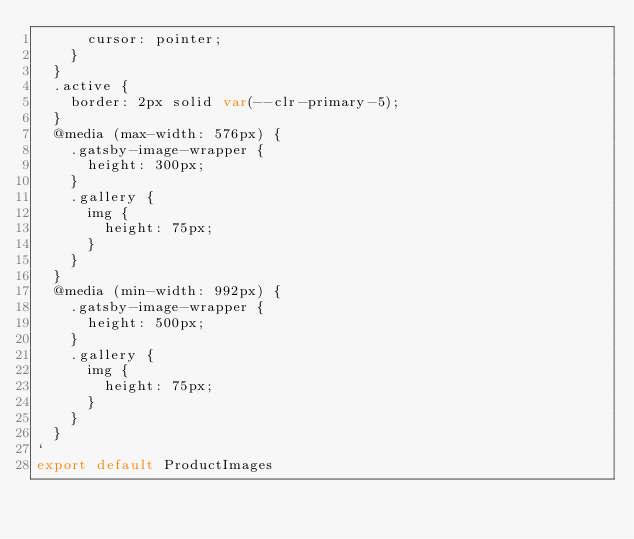Convert code to text. <code><loc_0><loc_0><loc_500><loc_500><_JavaScript_>      cursor: pointer;
    }
  }
  .active {
    border: 2px solid var(--clr-primary-5);
  }
  @media (max-width: 576px) {
    .gatsby-image-wrapper {
      height: 300px;
    }
    .gallery {
      img {
        height: 75px;
      }
    }
  }
  @media (min-width: 992px) {
    .gatsby-image-wrapper {
      height: 500px;
    }
    .gallery {
      img {
        height: 75px;
      }
    }
  }
`
export default ProductImages
</code> 